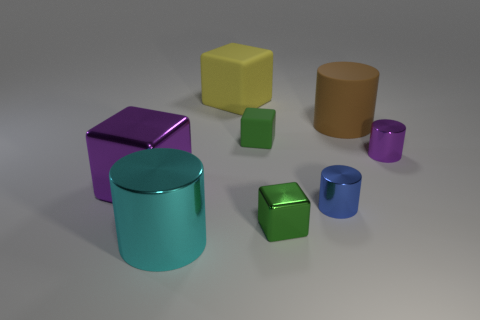Do the small matte object and the small shiny cube have the same color?
Your answer should be compact. Yes. There is a large yellow object that is the same shape as the small green shiny thing; what is its material?
Make the answer very short. Rubber. What is the material of the tiny green thing that is behind the large object left of the big cyan cylinder?
Offer a terse response. Rubber. There is a big brown matte thing; does it have the same shape as the large metal object right of the purple metallic block?
Ensure brevity in your answer.  Yes. How many other objects are there of the same material as the purple cube?
Offer a terse response. 4. Is the shape of the large thing that is on the right side of the yellow block the same as  the blue metallic object?
Your answer should be very brief. Yes. Are there an equal number of purple metallic blocks right of the blue metallic cylinder and rubber cylinders right of the large shiny cube?
Offer a terse response. No. There is a small rubber object; does it have the same color as the small cube in front of the small purple shiny object?
Keep it short and to the point. Yes. There is another small object that is the same shape as the blue shiny thing; what is its color?
Your answer should be very brief. Purple. What material is the other block that is the same color as the small shiny block?
Ensure brevity in your answer.  Rubber. 